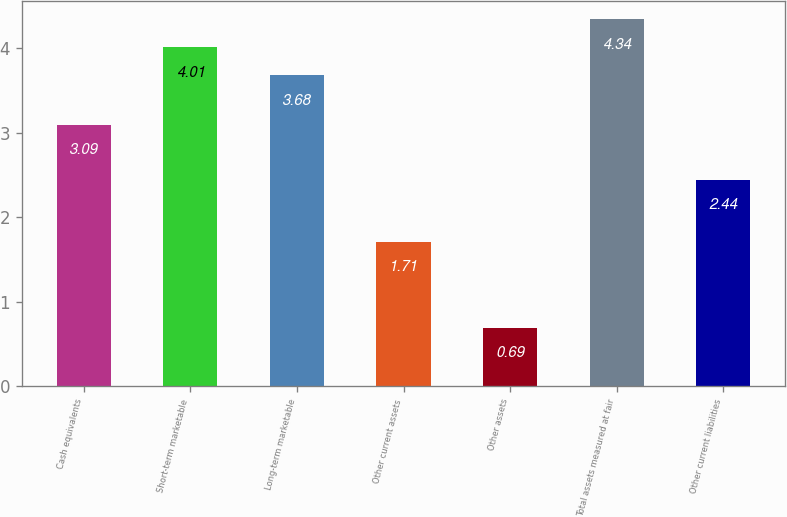Convert chart. <chart><loc_0><loc_0><loc_500><loc_500><bar_chart><fcel>Cash equivalents<fcel>Short-term marketable<fcel>Long-term marketable<fcel>Other current assets<fcel>Other assets<fcel>Total assets measured at fair<fcel>Other current liabilities<nl><fcel>3.09<fcel>4.01<fcel>3.68<fcel>1.71<fcel>0.69<fcel>4.34<fcel>2.44<nl></chart> 